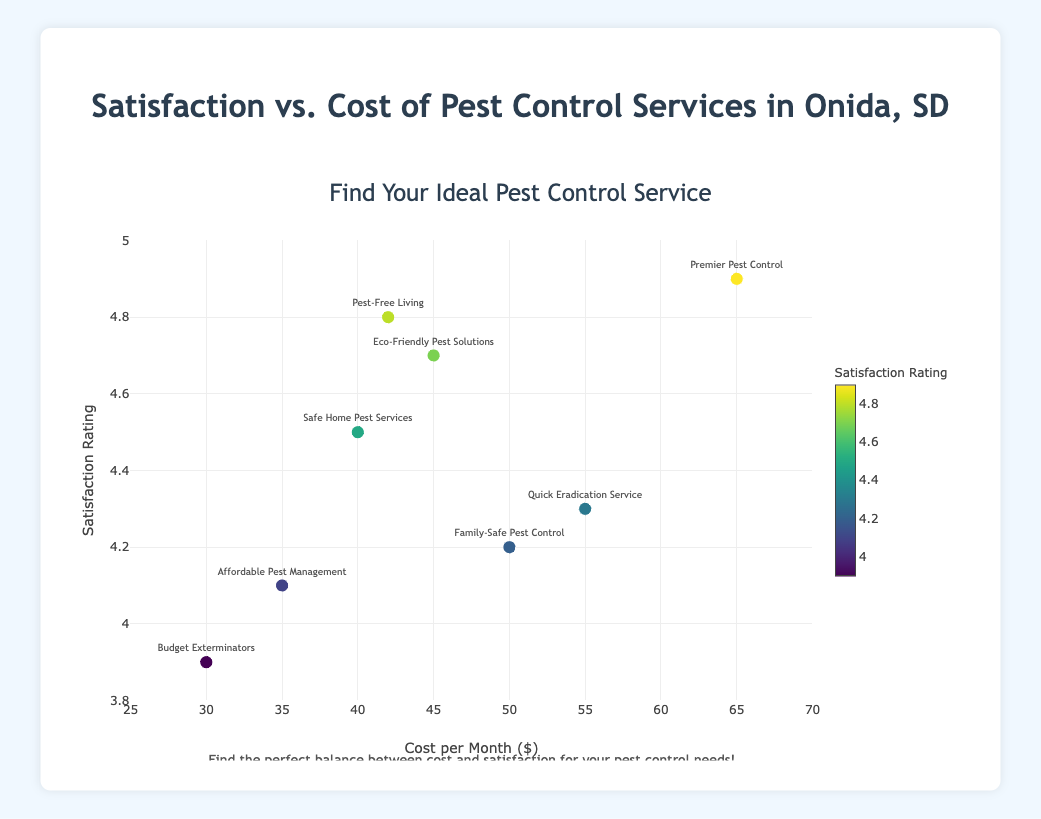Which pest control service has the highest satisfaction rating? The scatter plot shows "Premier Pest Control" with a satisfaction rating of 4.9, the highest among all services.
Answer: Premier Pest Control What is the cost per month for "Budget Exterminators", and how does its satisfaction rating compare to "Affordable Pest Management"? "Budget Exterminators" costs $30 per month with a 3.9 satisfaction rating. "Affordable Pest Management" costs $35 per month with a 4.1 satisfaction rating, which is higher.
Answer: $30; 3.9 vs. 4.1 Are there any services with a cost less than $40 and a satisfaction rating higher than 4.5? Looking at the scatter plot, the only service under $40 is "Affordable Pest Management" at $35, but its satisfaction rating is 4.1, which is lower than 4.5.
Answer: No Which service has the closest satisfaction rating to 4.5, and what is its cost? "Safe Home Pest Services" has a satisfaction rating of 4.5, with a cost of $40 per month.
Answer: Safe Home Pest Services; $40 Is there any service priced between $40 and $50 with a satisfaction rating above 4.2? "Eco-Friendly Pest Solutions" costs $45 and has a satisfaction rating of 4.7. "Pest-Free Living" costs $42 and has a satisfaction rating of 4.8.
Answer: Eco-Friendly Pest Solutions; Pest-Free Living What is the average cost for services with a satisfaction rating of 4.7 or higher? The services with ratings of 4.7 or higher are "Eco-Friendly Pest Solutions" ($45), "Premier Pest Control" ($65), and "Pest-Free Living" ($42). The average cost is (45 + 65 + 42)/3 = $50.67.
Answer: $50.67 How many services have a satisfaction rating above 4.0 and below 4.5? "Safe Home Pest Services" (4.5), "Affordable Pest Management" (4.1), "Quick Eradication Service" (4.3), and "Family-Safe Pest Control" (4.2) fit this range, totaling 4 services.
Answer: 4 Which service is the most budget-friendly with a satisfaction rating of at least 4.2? The least expensive service with a satisfaction rating of at least 4.2 is "Affordable Pest Management," costing $35 per month.
Answer: Affordable Pest Management Between "Eco-Friendly Pest Solutions" and "Quick Eradication Service," which has the higher satisfaction rating, and by how much? "Eco-Friendly Pest Solutions" has a rating of 4.7, and "Quick Eradication Service" has a rating of 4.3. The difference is 4.7 - 4.3 = 0.4.
Answer: Eco-Friendly Pest Solutions; 0.4 Is there any apparent trend between cost and satisfaction rating? By looking at the plot, a general trend shows that higher-cost services tend to have higher satisfaction ratings, though with some variability.
Answer: Higher cost generally correlates with higher satisfaction 